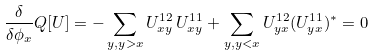<formula> <loc_0><loc_0><loc_500><loc_500>\frac { \delta } { \delta \phi _ { x } } Q [ U ] = - \sum _ { y , y > x } U ^ { 1 2 } _ { x y } \, U ^ { 1 1 } _ { x y } + \sum _ { y , y < x } U ^ { 1 2 } _ { y x } ( U ^ { 1 1 } _ { y x } ) ^ { * } = 0</formula> 